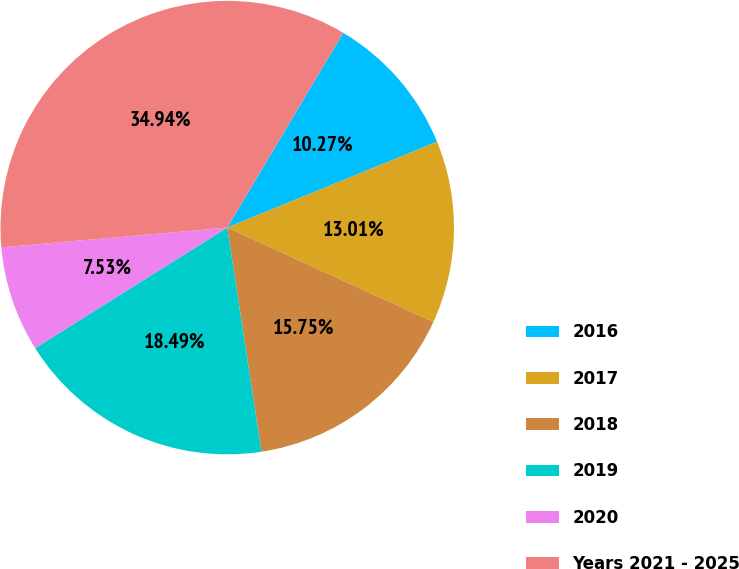Convert chart. <chart><loc_0><loc_0><loc_500><loc_500><pie_chart><fcel>2016<fcel>2017<fcel>2018<fcel>2019<fcel>2020<fcel>Years 2021 - 2025<nl><fcel>10.27%<fcel>13.01%<fcel>15.75%<fcel>18.49%<fcel>7.53%<fcel>34.93%<nl></chart> 